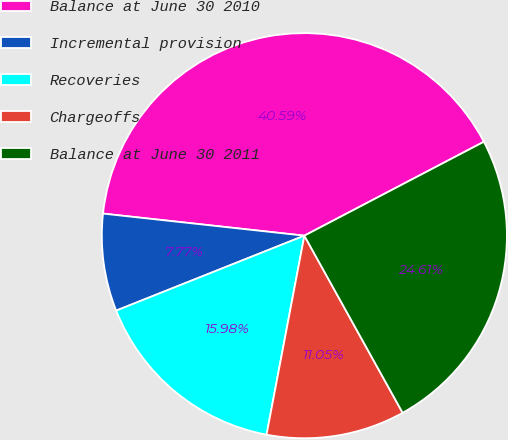Convert chart. <chart><loc_0><loc_0><loc_500><loc_500><pie_chart><fcel>Balance at June 30 2010<fcel>Incremental provision<fcel>Recoveries<fcel>Chargeoffs<fcel>Balance at June 30 2011<nl><fcel>40.59%<fcel>7.77%<fcel>15.98%<fcel>11.05%<fcel>24.61%<nl></chart> 